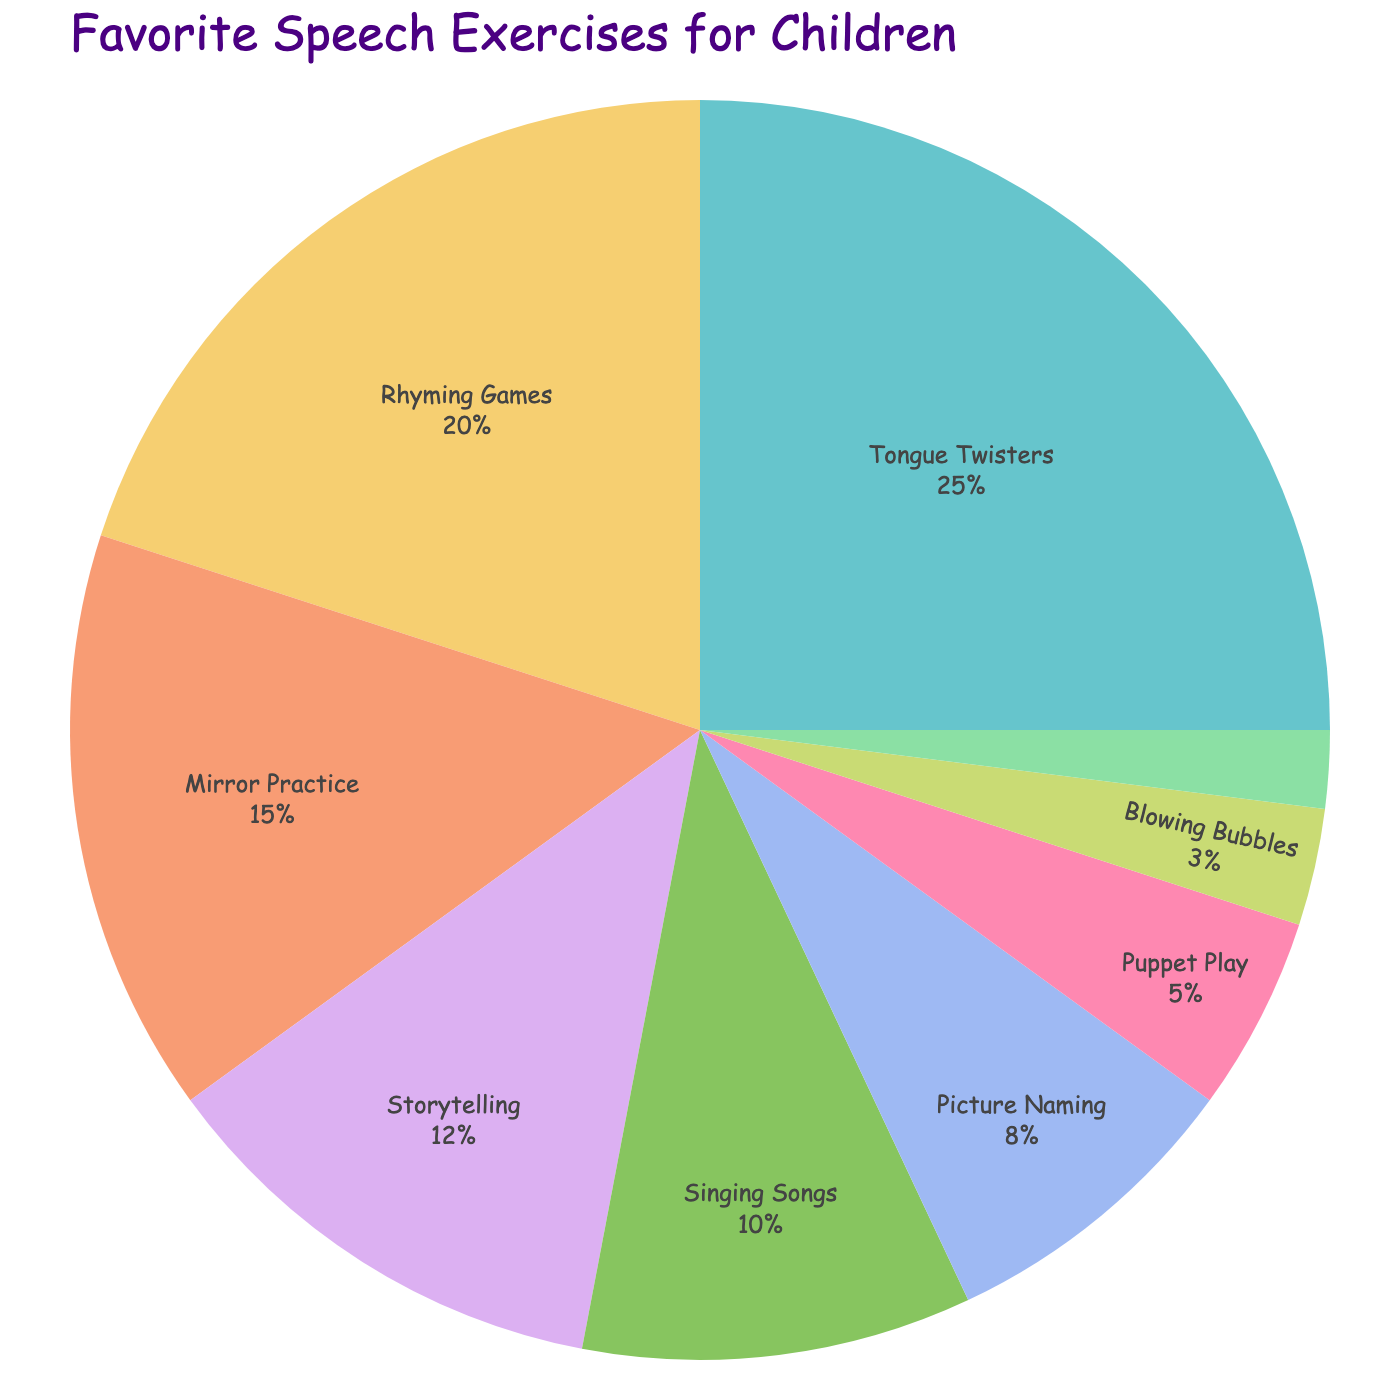What percentage of children prefer "Rhyming Games"? From the pie chart, we see that "Rhyming Games" makes up 20% of the favorite speech exercises among children.
Answer: 20% Which speech exercise is the least popular among children? By looking at the pie chart, we observe that "Sound Imitation" has the smallest segment, indicating it is the least popular.
Answer: Sound Imitation Are there more children who prefer "Tongue Twisters" than those who prefer "Singing Songs" and "Picture Naming" combined? The percentage for "Tongue Twisters" is 25%. The combined percentage for "Singing Songs" (10%) and "Picture Naming" (8%) is 18%. Since 25% is greater than 18%, more children prefer "Tongue Twisters".
Answer: Yes What is the total percentage of children who prefer exercises other than "Tongue Twisters", "Rhyming Games", and "Mirror Practice"? The percentages for "Tongue Twisters" (25%), "Rhyming Games" (20%), and "Mirror Practice" (15%) sum to 60%. The total percentage for all exercises is 100%, so the percentage for other exercises is 100% - 60% = 40%.
Answer: 40% Which exercise has a larger preference: "Storytelling" or "Puppet Play"? From the pie chart, "Storytelling" is preferred by 12% of the children, while "Puppet Play" is preferred by 5%. Therefore, "Storytelling" has a larger preference.
Answer: Storytelling What is the combined percentage of the three most popular speech exercises? The three most popular exercises are "Tongue Twisters" (25%), "Rhyming Games" (20%), and "Mirror Practice" (15%). Their combined percentage is 25% + 20% + 15% = 60%.
Answer: 60% How many exercises have a preference percentage below 10%? The exercises with preference percentages below 10% are "Picture Naming" (8%), "Puppet Play" (5%), "Blowing Bubbles" (3%), and "Sound Imitation" (2%), thus making it four exercises.
Answer: 4 Which category makes up exactly 12% of the favorite speech exercises? Looking at the pie chart, "Storytelling" is the exercise that makes up exactly 12% of the children's favorites.
Answer: Storytelling 